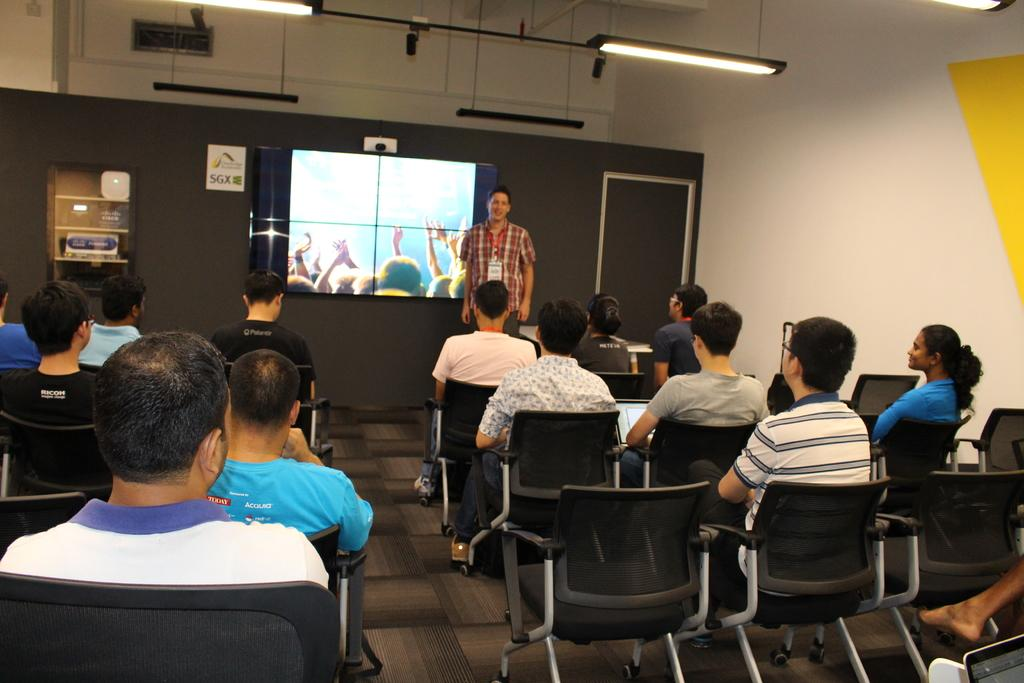What are the people in the image doing? The people in the image are sitting on chairs. Is there anyone standing in the image? Yes, there is a person standing in the image. What electronic device is visible in the image? There is a TV screen visible in the image. What type of kittens can be seen playing with the manager in the image? There are no kittens or managers present in the image. Are the police involved in the scene depicted in the image? There is no indication of police involvement in the image. 